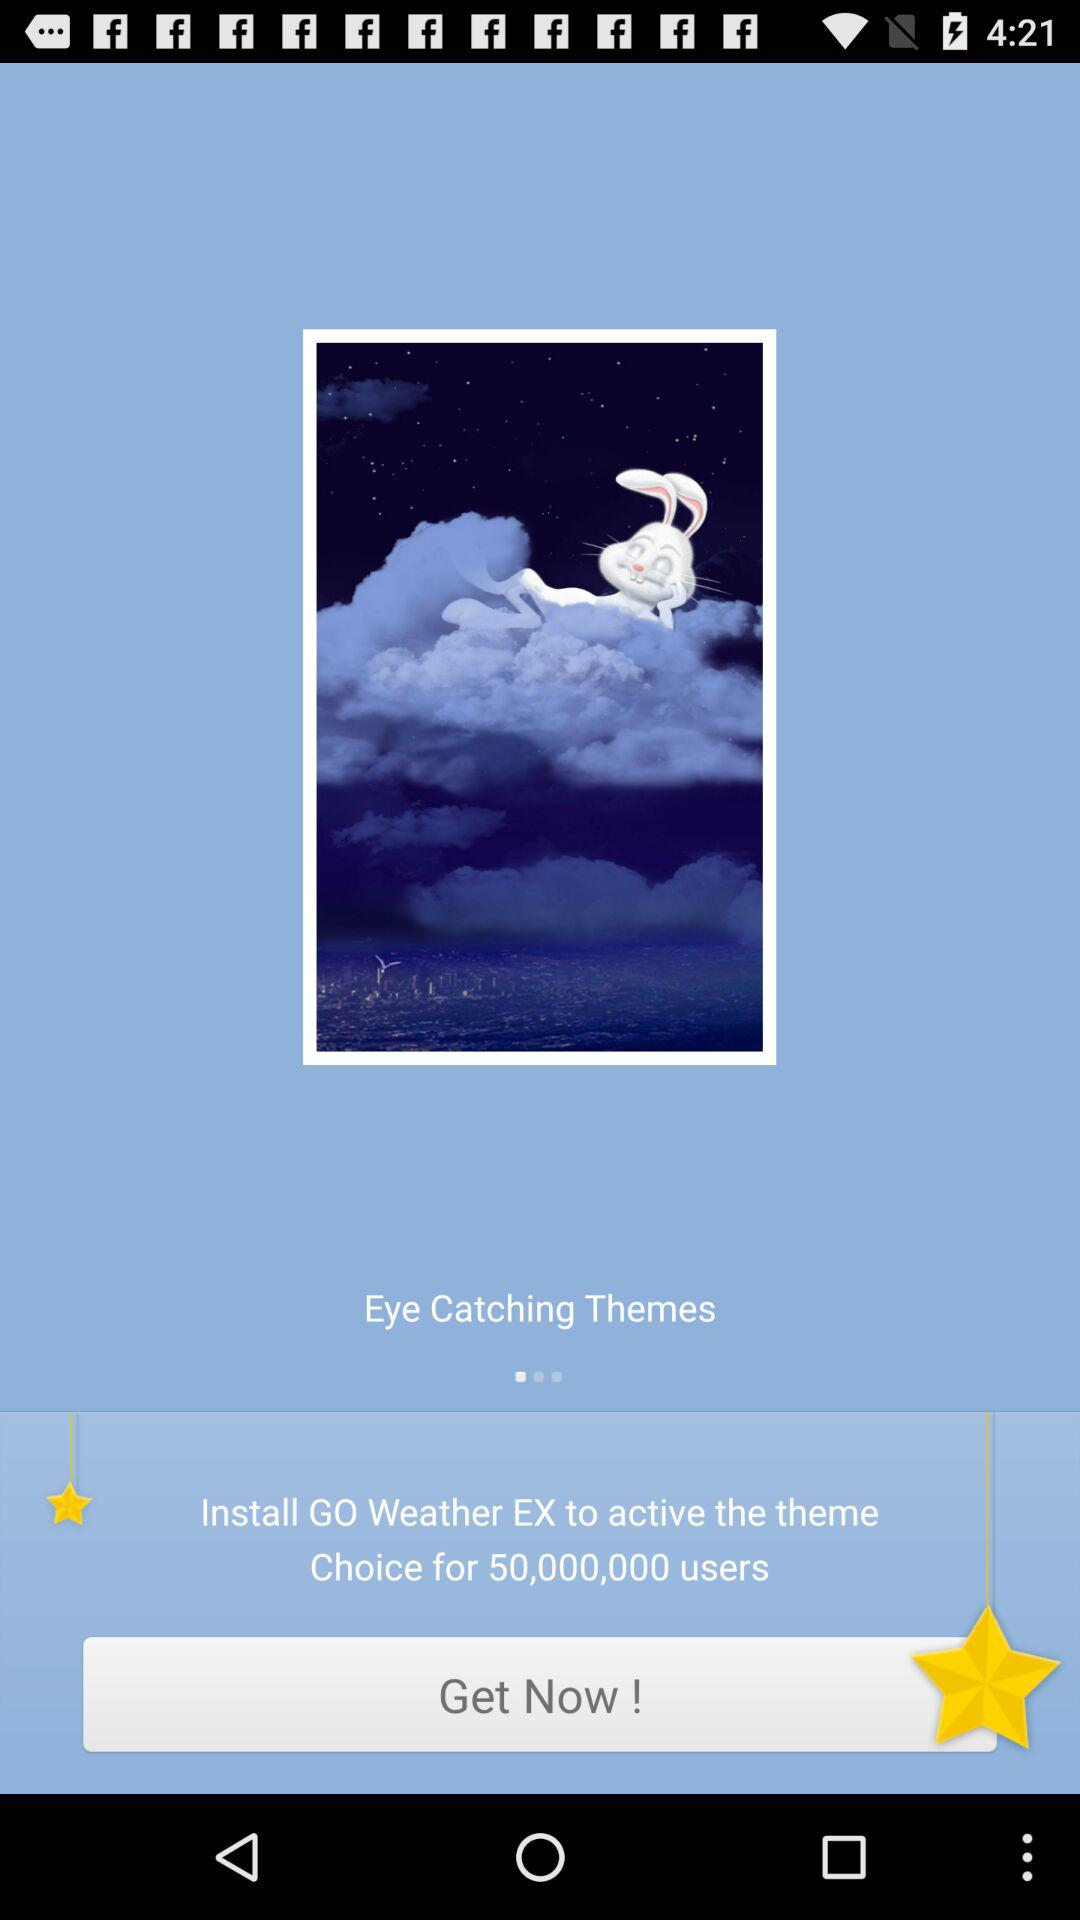How many users choose "GO Weather EX"? There are 50,000,000 users who choose "GO Weather EX". 